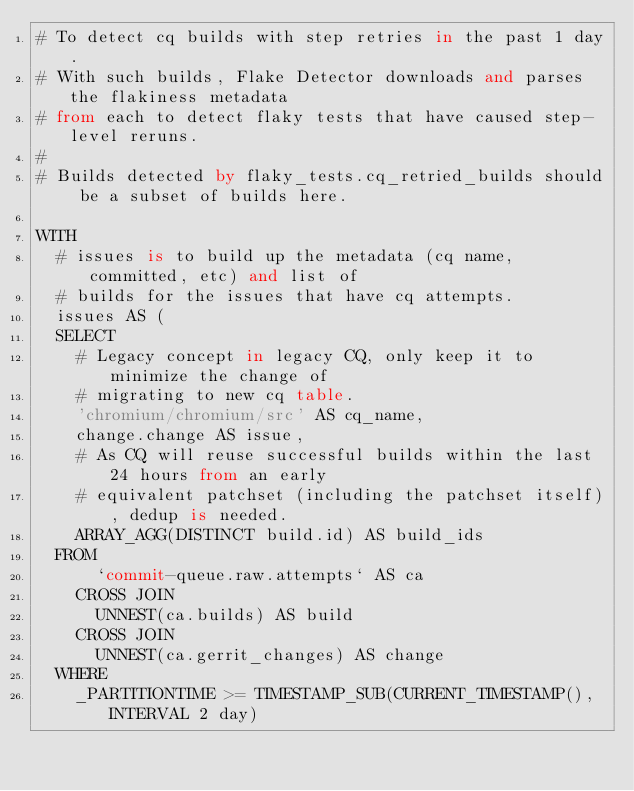<code> <loc_0><loc_0><loc_500><loc_500><_SQL_># To detect cq builds with step retries in the past 1 day.
# With such builds, Flake Detector downloads and parses the flakiness metadata
# from each to detect flaky tests that have caused step-level reruns.
#
# Builds detected by flaky_tests.cq_retried_builds should be a subset of builds here.

WITH
  # issues is to build up the metadata (cq name, committed, etc) and list of
  # builds for the issues that have cq attempts.
  issues AS (
  SELECT
    # Legacy concept in legacy CQ, only keep it to minimize the change of
    # migrating to new cq table.
    'chromium/chromium/src' AS cq_name,
    change.change AS issue,
    # As CQ will reuse successful builds within the last 24 hours from an early
    # equivalent patchset (including the patchset itself), dedup is needed.
    ARRAY_AGG(DISTINCT build.id) AS build_ids
  FROM
      `commit-queue.raw.attempts` AS ca
    CROSS JOIN
      UNNEST(ca.builds) AS build
    CROSS JOIN
      UNNEST(ca.gerrit_changes) AS change
  WHERE
    _PARTITIONTIME >= TIMESTAMP_SUB(CURRENT_TIMESTAMP(), INTERVAL 2 day)</code> 